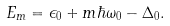Convert formula to latex. <formula><loc_0><loc_0><loc_500><loc_500>E _ { m } = \epsilon _ { 0 } + m \hbar { \omega } _ { 0 } - \Delta _ { 0 } .</formula> 